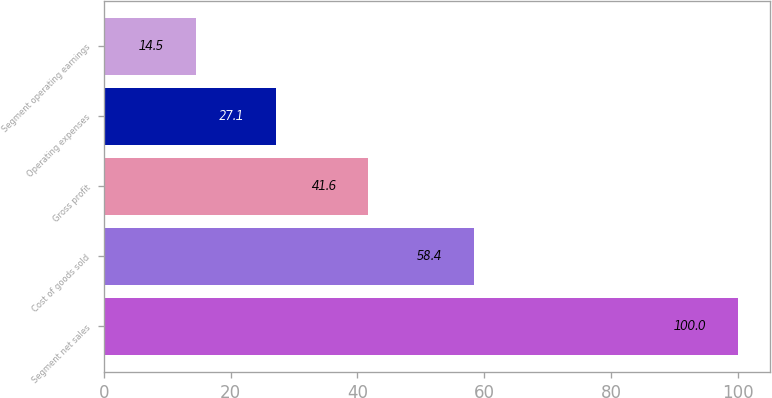Convert chart to OTSL. <chart><loc_0><loc_0><loc_500><loc_500><bar_chart><fcel>Segment net sales<fcel>Cost of goods sold<fcel>Gross profit<fcel>Operating expenses<fcel>Segment operating earnings<nl><fcel>100<fcel>58.4<fcel>41.6<fcel>27.1<fcel>14.5<nl></chart> 